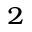<formula> <loc_0><loc_0><loc_500><loc_500>_ { 2 }</formula> 